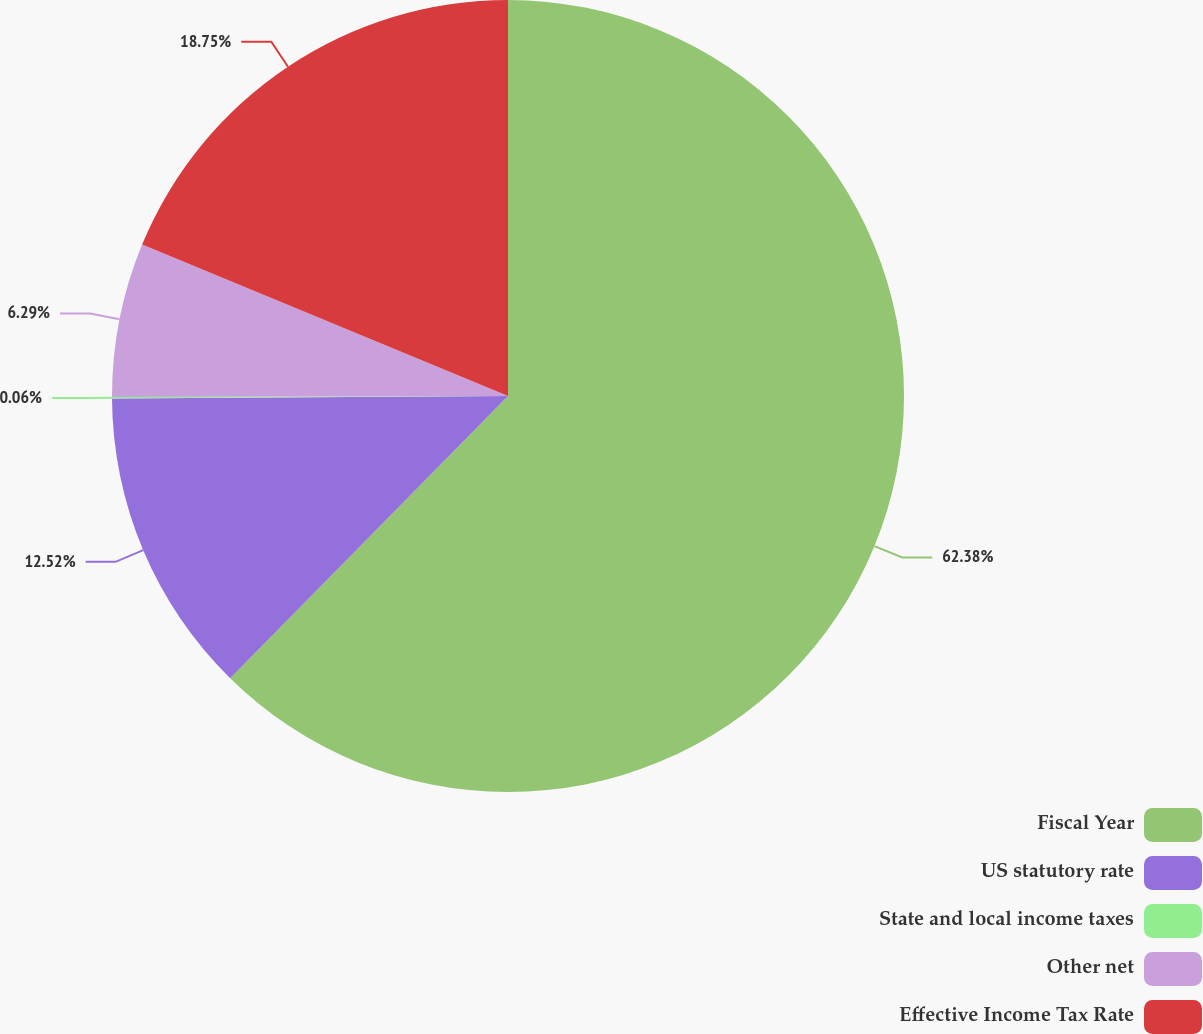<chart> <loc_0><loc_0><loc_500><loc_500><pie_chart><fcel>Fiscal Year<fcel>US statutory rate<fcel>State and local income taxes<fcel>Other net<fcel>Effective Income Tax Rate<nl><fcel>62.37%<fcel>12.52%<fcel>0.06%<fcel>6.29%<fcel>18.75%<nl></chart> 